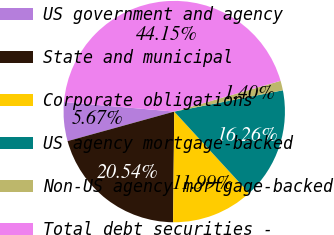<chart> <loc_0><loc_0><loc_500><loc_500><pie_chart><fcel>US government and agency<fcel>State and municipal<fcel>Corporate obligations<fcel>US agency mortgage-backed<fcel>Non-US agency mortgage-backed<fcel>Total debt securities -<nl><fcel>5.67%<fcel>20.54%<fcel>11.99%<fcel>16.26%<fcel>1.4%<fcel>44.15%<nl></chart> 